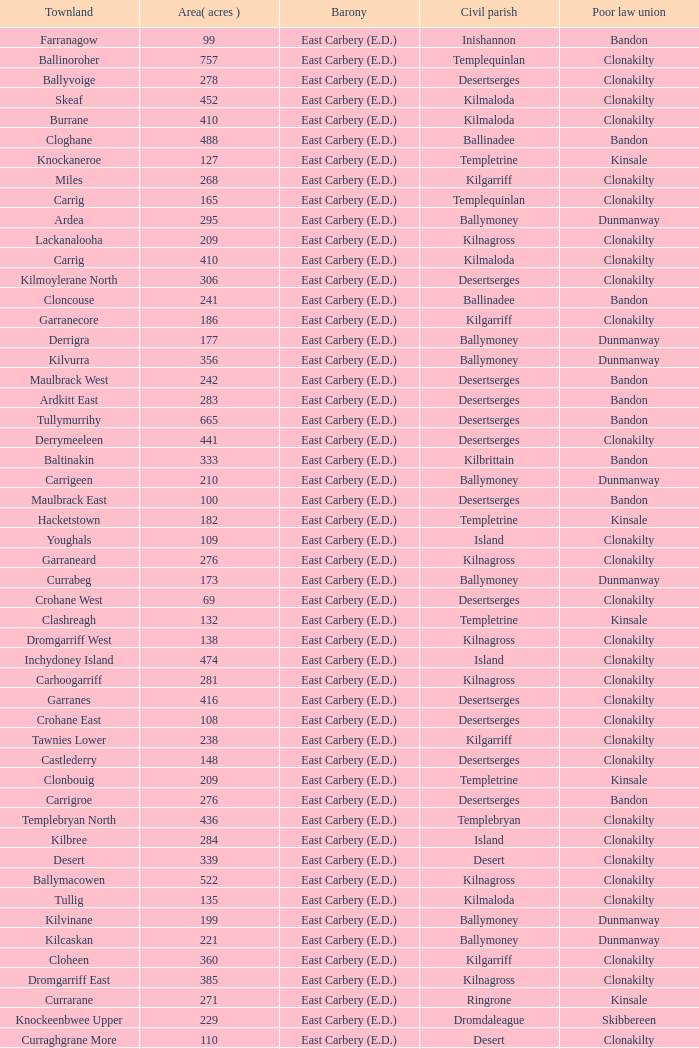What is the poor law union of the Kilmaloda townland? Clonakilty. 